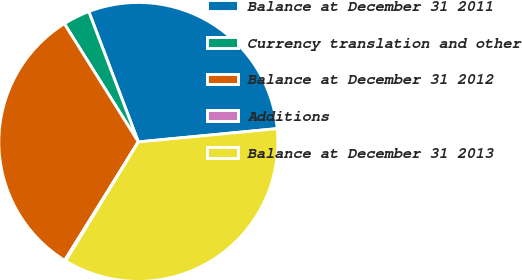<chart> <loc_0><loc_0><loc_500><loc_500><pie_chart><fcel>Balance at December 31 2011<fcel>Currency translation and other<fcel>Balance at December 31 2012<fcel>Additions<fcel>Balance at December 31 2013<nl><fcel>29.26%<fcel>3.12%<fcel>32.25%<fcel>0.12%<fcel>35.25%<nl></chart> 